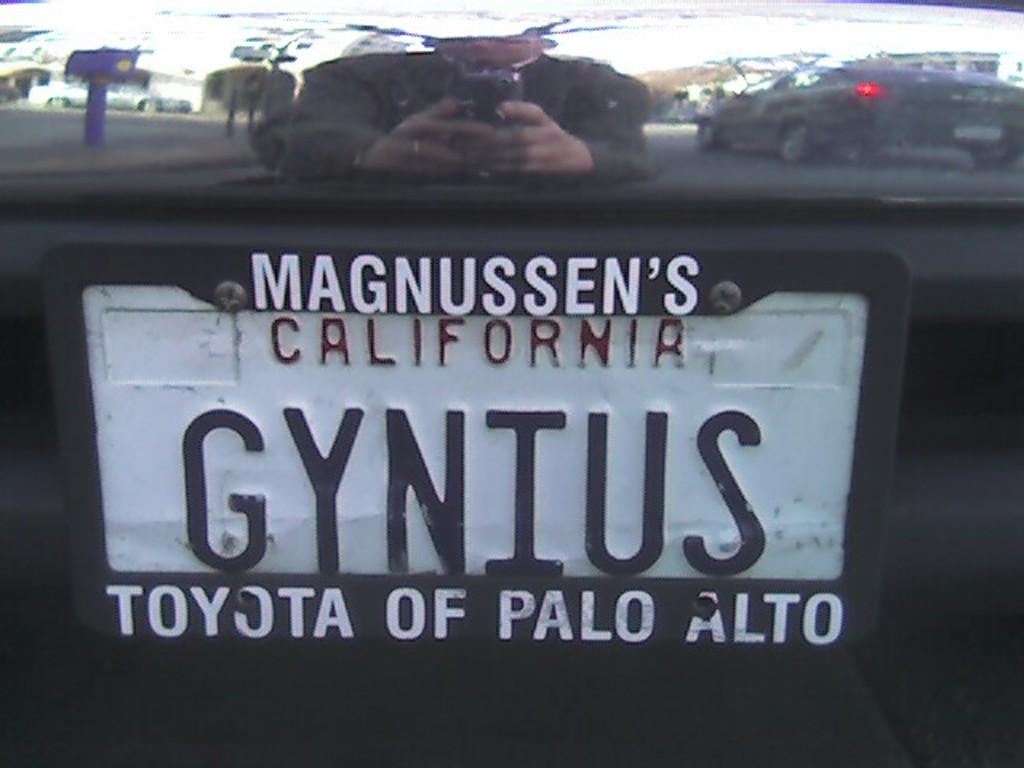Provide a one-sentence caption for the provided image. A license plate has MAGNUSSEN'S CALIFORNIA GYNIUS TOYOTA OF PALO ALTO on it. 